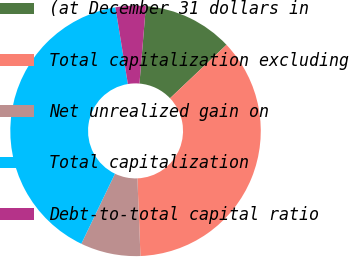<chart> <loc_0><loc_0><loc_500><loc_500><pie_chart><fcel>(at December 31 dollars in<fcel>Total capitalization excluding<fcel>Net unrealized gain on<fcel>Total capitalization<fcel>Debt-to-total capital ratio<nl><fcel>11.62%<fcel>36.44%<fcel>7.75%<fcel>40.3%<fcel>3.89%<nl></chart> 